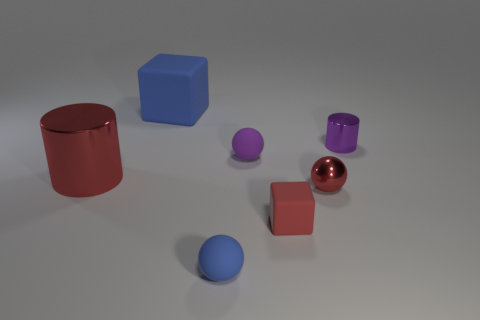Subtract all tiny red metal balls. How many balls are left? 2 Add 1 blue objects. How many objects exist? 8 Subtract 1 cylinders. How many cylinders are left? 1 Subtract all red blocks. How many blocks are left? 1 Add 7 tiny spheres. How many tiny spheres exist? 10 Subtract 0 yellow cylinders. How many objects are left? 7 Subtract all cubes. How many objects are left? 5 Subtract all cyan cylinders. Subtract all red blocks. How many cylinders are left? 2 Subtract all small red shiny blocks. Subtract all tiny metallic balls. How many objects are left? 6 Add 2 blue matte objects. How many blue matte objects are left? 4 